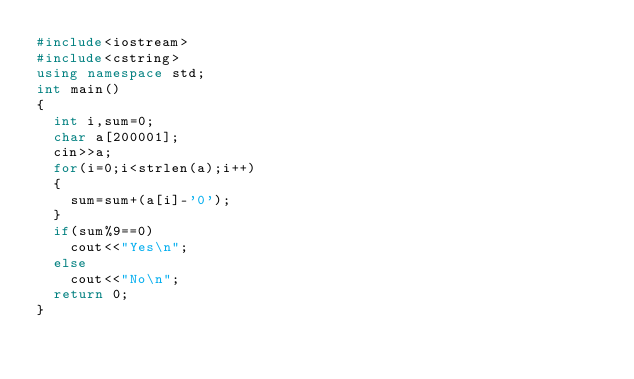<code> <loc_0><loc_0><loc_500><loc_500><_C++_>#include<iostream>
#include<cstring>
using namespace std;
int main()
{
  int i,sum=0;
  char a[200001];
  cin>>a;
  for(i=0;i<strlen(a);i++)
  {
    sum=sum+(a[i]-'0');
  }
  if(sum%9==0)
    cout<<"Yes\n";
  else
    cout<<"No\n";
  return 0;
}
  </code> 